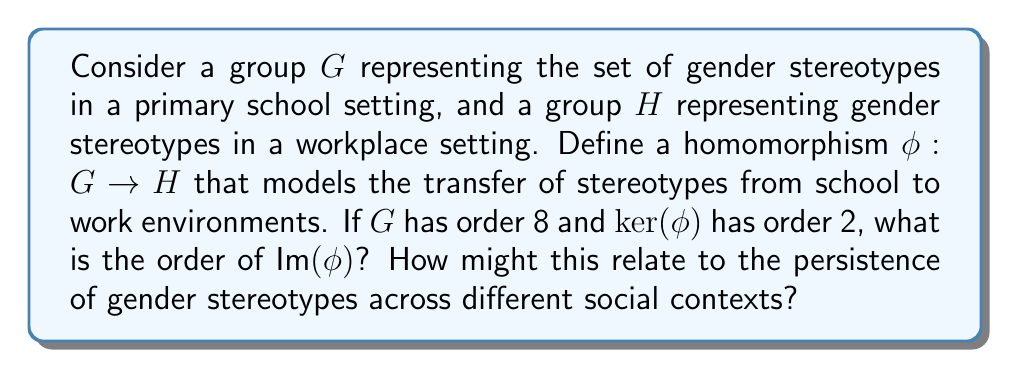Show me your answer to this math problem. To solve this problem, we'll use the First Isomorphism Theorem and its implications:

1) The First Isomorphism Theorem states that for a group homomorphism $\phi: G \rightarrow H$, we have:

   $$G/\ker(\phi) \cong \text{Im}(\phi)$$

2) This implies that the order of the image is related to the orders of $G$ and $\ker(\phi)$:

   $$|\text{Im}(\phi)| = |G|/|\ker(\phi)|$$

3) We're given that:
   - $|G| = 8$
   - $|\ker(\phi)| = 2$

4) Substituting these values into the equation from step 2:

   $$|\text{Im}(\phi)| = 8/2 = 4$$

5) Interpretation in the context of gender stereotypes:
   - The order of $G$ (8) represents the total number of distinct gender stereotypes in the school setting.
   - The order of $\ker(\phi)$ (2) represents the number of stereotypes that don't transfer to the workplace (they map to the identity in $H$).
   - The order of $\text{Im}(\phi)$ (4) represents the number of distinct stereotypes that persist in the workplace setting.

This result suggests that half of the stereotypes from the school setting persist in the workplace, indicating a significant transfer of gender stereotypes across these different social contexts. This persistence could be studied to understand the long-term effects of early exposure to gender stereotypes on career choices and workplace dynamics.
Answer: The order of $\text{Im}(\phi)$ is 4. 